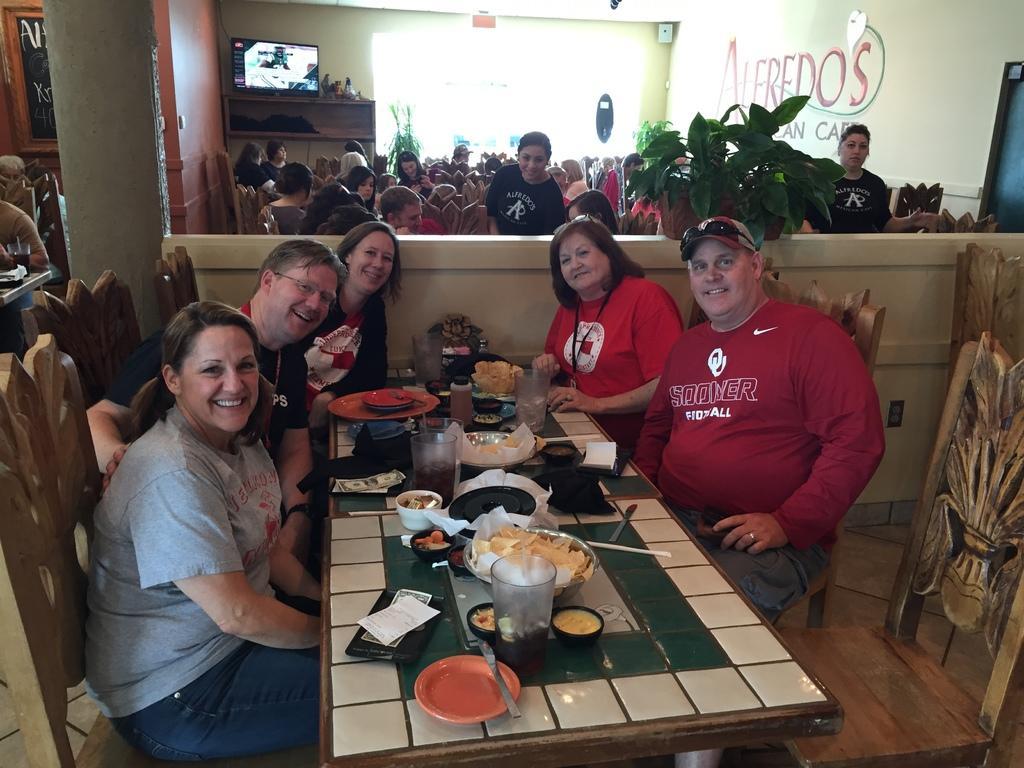Describe this image in one or two sentences. Here we can see a group of people sitting on chairs with table in front of them having food, plates, glasses and on the top left we can see a television present and some people are standing and we can see plants present also 